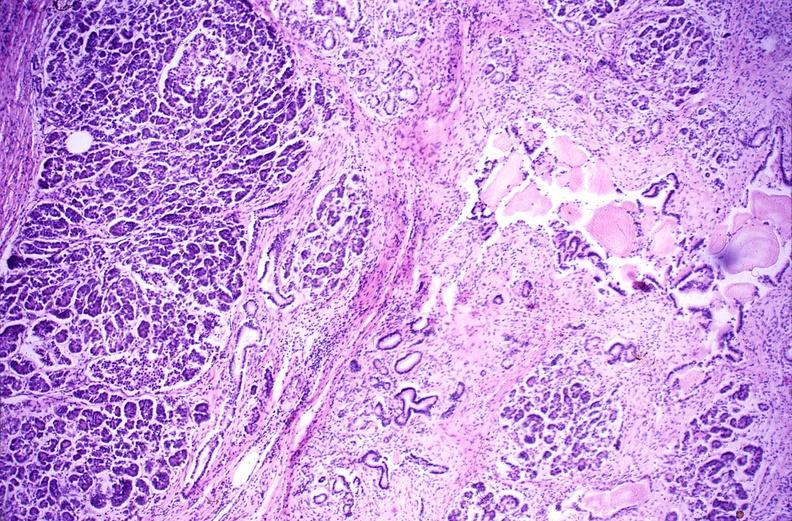does this image show chronic pancreatitis?
Answer the question using a single word or phrase. Yes 